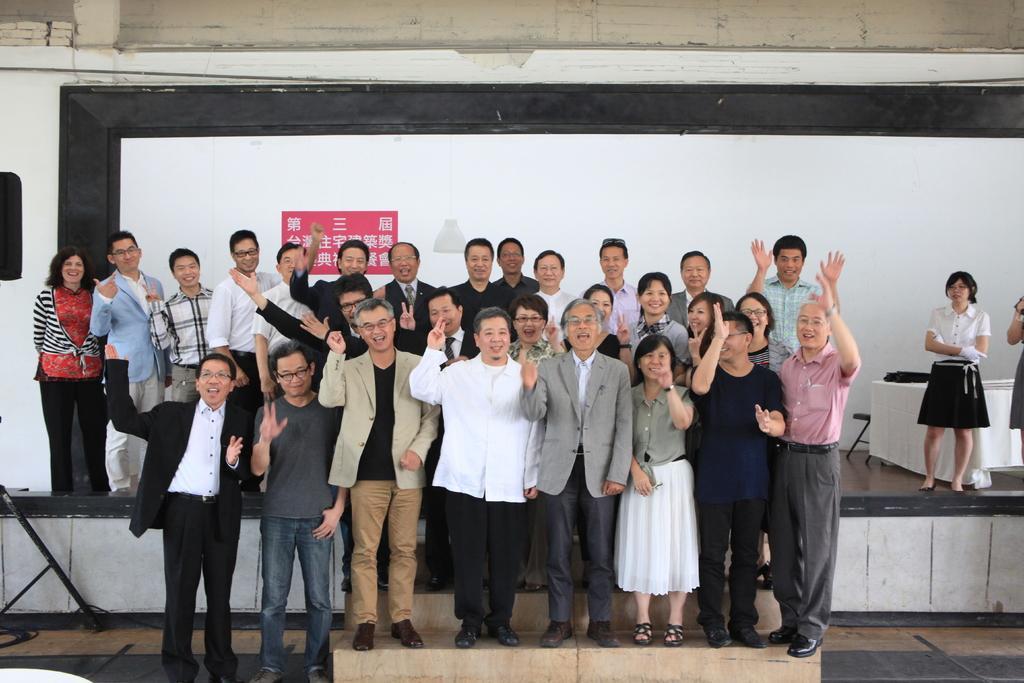How would you summarize this image in a sentence or two? In this image there is a metal stand and an object on the left corner. There is a table with an object on it, there is a chair, there are people on the right corner. There are people standing in the foreground. And there is a screen in the background. There is floor at the bottom. 